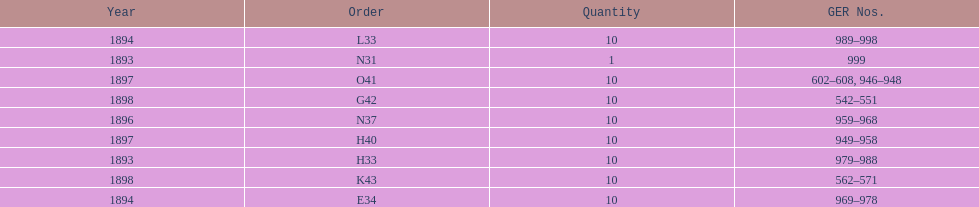What is the order of the last year listed? K43. 